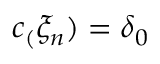Convert formula to latex. <formula><loc_0><loc_0><loc_500><loc_500>c _ { ( } \xi _ { n } ) = \delta _ { 0 }</formula> 